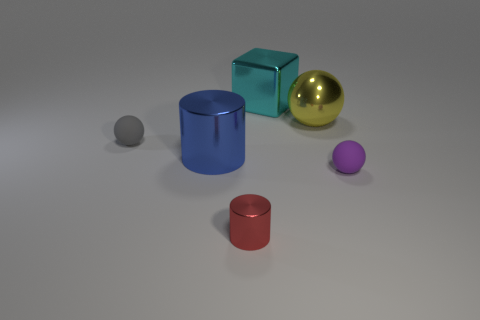Subtract all large yellow metallic spheres. How many spheres are left? 2 Add 1 small yellow matte objects. How many objects exist? 7 Subtract all purple balls. How many balls are left? 2 Subtract all cubes. How many objects are left? 5 Subtract 1 blocks. How many blocks are left? 0 Subtract all tiny purple rubber spheres. Subtract all cyan metal blocks. How many objects are left? 4 Add 5 large yellow objects. How many large yellow objects are left? 6 Add 2 purple rubber objects. How many purple rubber objects exist? 3 Subtract 1 gray balls. How many objects are left? 5 Subtract all brown cubes. Subtract all brown balls. How many cubes are left? 1 